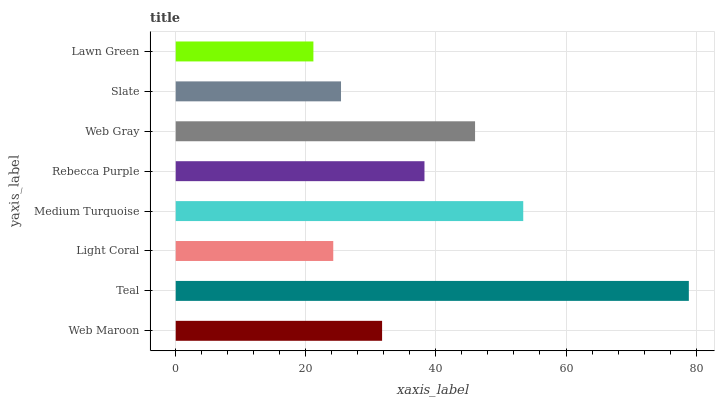Is Lawn Green the minimum?
Answer yes or no. Yes. Is Teal the maximum?
Answer yes or no. Yes. Is Light Coral the minimum?
Answer yes or no. No. Is Light Coral the maximum?
Answer yes or no. No. Is Teal greater than Light Coral?
Answer yes or no. Yes. Is Light Coral less than Teal?
Answer yes or no. Yes. Is Light Coral greater than Teal?
Answer yes or no. No. Is Teal less than Light Coral?
Answer yes or no. No. Is Rebecca Purple the high median?
Answer yes or no. Yes. Is Web Maroon the low median?
Answer yes or no. Yes. Is Medium Turquoise the high median?
Answer yes or no. No. Is Light Coral the low median?
Answer yes or no. No. 